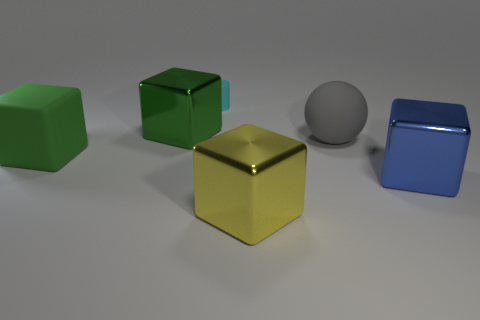Are there fewer blue metallic objects behind the large matte cube than tiny cylinders? Upon closer observation, we can confirm that there are indeed fewer blue metallic objects behind the large matte cube than tiny cylinders. Specific attention to color, material, and size is pivotal in visual analysis. 